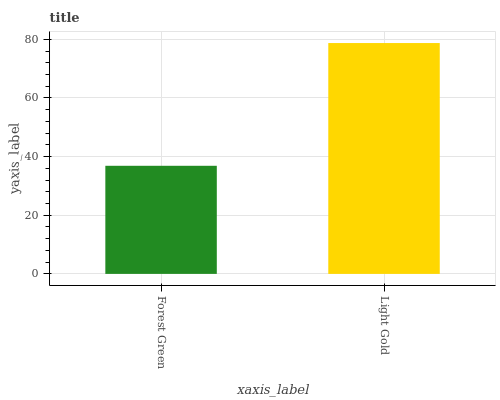Is Forest Green the minimum?
Answer yes or no. Yes. Is Light Gold the maximum?
Answer yes or no. Yes. Is Light Gold the minimum?
Answer yes or no. No. Is Light Gold greater than Forest Green?
Answer yes or no. Yes. Is Forest Green less than Light Gold?
Answer yes or no. Yes. Is Forest Green greater than Light Gold?
Answer yes or no. No. Is Light Gold less than Forest Green?
Answer yes or no. No. Is Light Gold the high median?
Answer yes or no. Yes. Is Forest Green the low median?
Answer yes or no. Yes. Is Forest Green the high median?
Answer yes or no. No. Is Light Gold the low median?
Answer yes or no. No. 